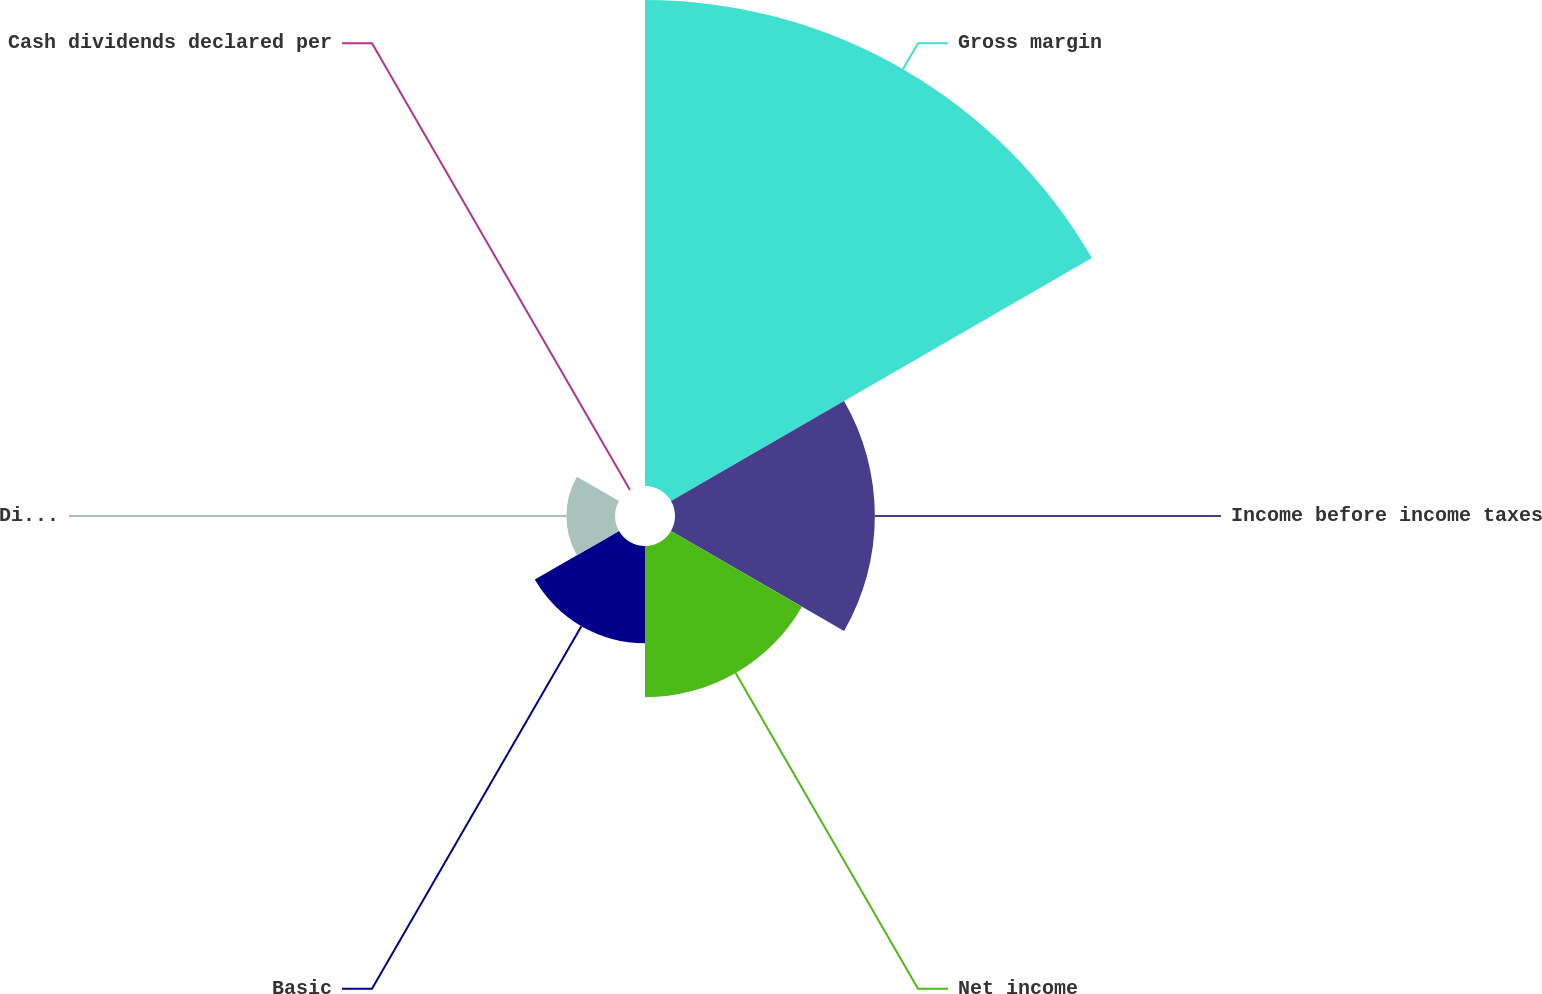Convert chart. <chart><loc_0><loc_0><loc_500><loc_500><pie_chart><fcel>Gross margin<fcel>Income before income taxes<fcel>Net income<fcel>Basic<fcel>Diluted<fcel>Cash dividends declared per<nl><fcel>49.44%<fcel>20.33%<fcel>15.39%<fcel>9.89%<fcel>4.94%<fcel>0.0%<nl></chart> 